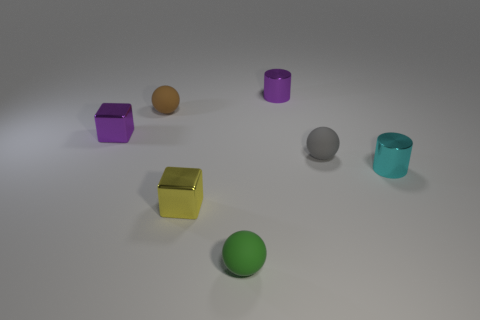Do the brown matte sphere and the purple block have the same size?
Offer a terse response. Yes. There is a cyan metal object; is its shape the same as the purple metallic object in front of the purple metal cylinder?
Your answer should be compact. No. What color is the other shiny cylinder that is the same size as the cyan metallic cylinder?
Give a very brief answer. Purple. Are there fewer cylinders behind the yellow metal block than rubber balls left of the small brown rubber sphere?
Your answer should be very brief. No. What shape is the tiny metal object on the left side of the small block that is in front of the tiny cyan metal cylinder that is right of the gray rubber object?
Offer a terse response. Cube. There is a shiny block on the left side of the tiny yellow shiny object; is its color the same as the cylinder that is behind the small gray object?
Offer a terse response. Yes. What number of metal things are small cyan things or brown balls?
Offer a very short reply. 1. What is the color of the small rubber object to the left of the tiny block that is right of the tiny purple metallic object that is to the left of the brown rubber sphere?
Your answer should be very brief. Brown. The other small thing that is the same shape as the cyan thing is what color?
Your answer should be compact. Purple. How many other objects are the same material as the small purple cube?
Offer a terse response. 3. 